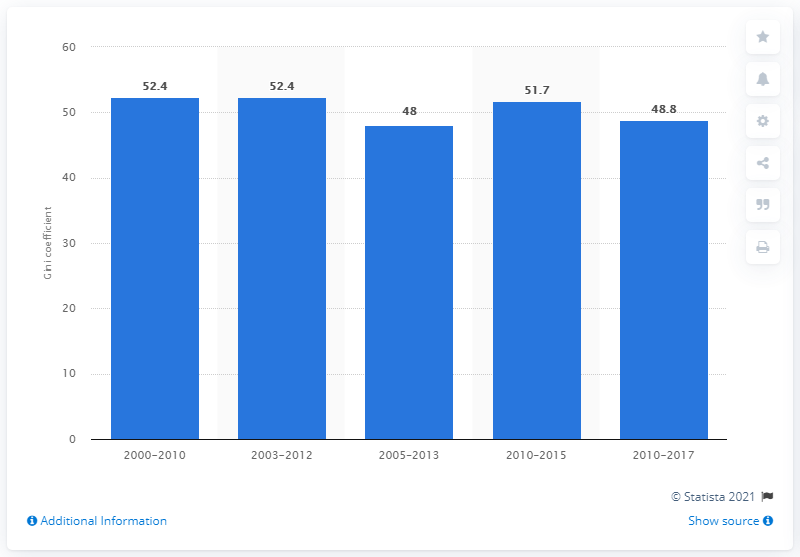List a handful of essential elements in this visual. In 2015, the Gini coefficient, a measure of income inequality, was 51.7%. 